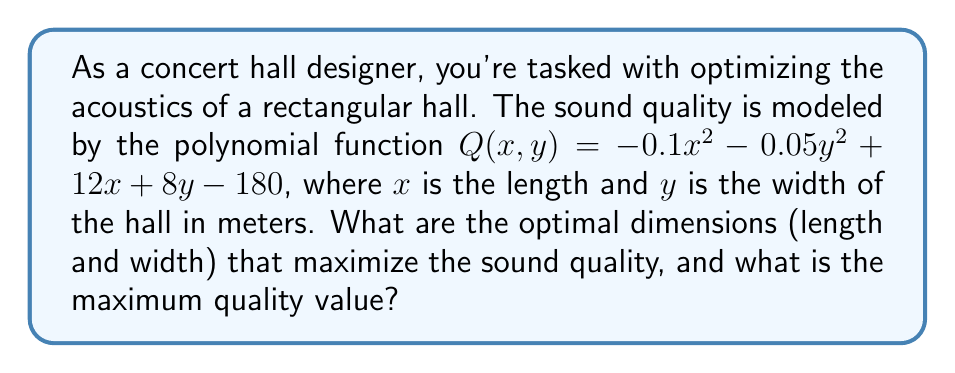Can you answer this question? To solve this problem, we'll use calculus techniques for finding the maximum of a two-variable function. Here's the step-by-step approach:

1) First, we need to find the partial derivatives of $Q$ with respect to $x$ and $y$:

   $$\frac{\partial Q}{\partial x} = -0.2x + 12$$
   $$\frac{\partial Q}{\partial y} = -0.1y + 8$$

2) At the maximum point, both partial derivatives will equal zero. So we set up the system of equations:

   $$-0.2x + 12 = 0$$
   $$-0.1y + 8 = 0$$

3) Solving these equations:

   From $-0.2x + 12 = 0$:
   $$x = 12 / 0.2 = 60$$

   From $-0.1y + 8 = 0$:
   $$y = 8 / 0.1 = 80$$

4) To confirm this is a maximum (not a minimum), we can check the second partial derivatives:

   $$\frac{\partial^2 Q}{\partial x^2} = -0.2$$
   $$\frac{\partial^2 Q}{\partial y^2} = -0.1$$

   Both are negative, confirming a maximum.

5) Now that we have the optimal dimensions, we can calculate the maximum quality by plugging these values back into our original function:

   $$Q(60,80) = -0.1(60)^2 - 0.05(80)^2 + 12(60) + 8(80) - 180$$
   $$= -360 - 320 + 720 + 640 - 180$$
   $$= 500$$

Therefore, the optimal dimensions are 60 meters in length and 80 meters in width, achieving a maximum quality value of 500.
Answer: Optimal dimensions: length = 60 meters, width = 80 meters
Maximum quality value: 500 